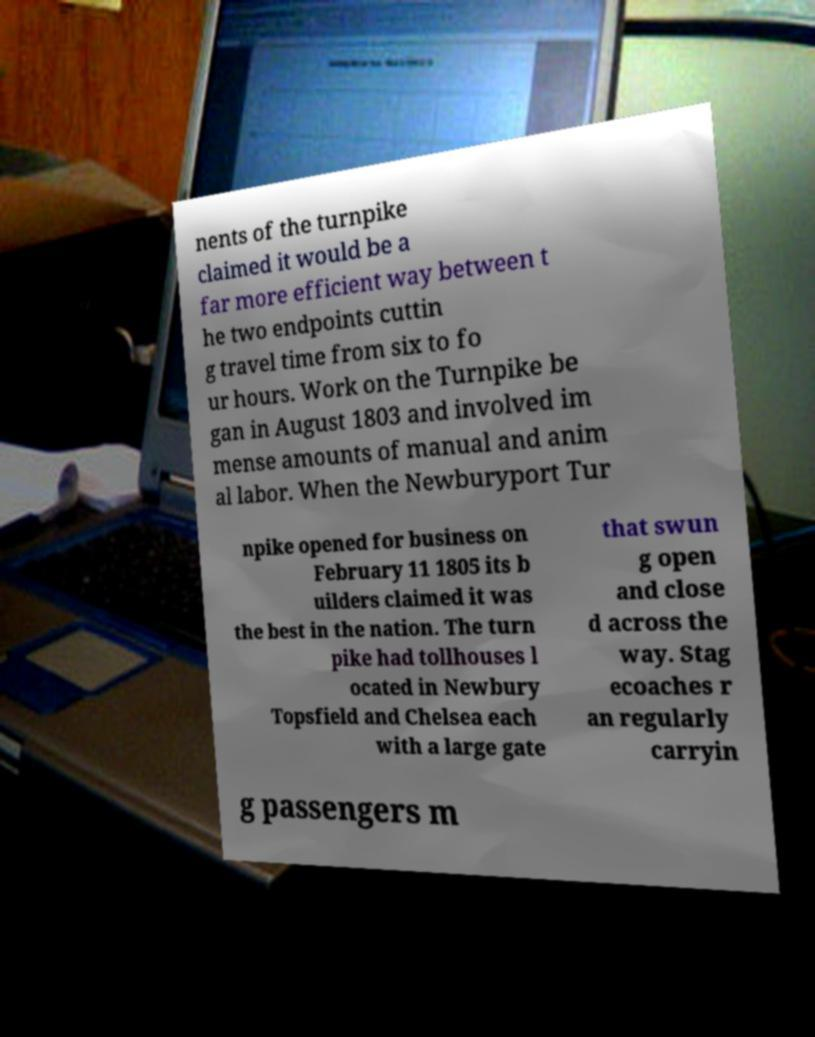What messages or text are displayed in this image? I need them in a readable, typed format. nents of the turnpike claimed it would be a far more efficient way between t he two endpoints cuttin g travel time from six to fo ur hours. Work on the Turnpike be gan in August 1803 and involved im mense amounts of manual and anim al labor. When the Newburyport Tur npike opened for business on February 11 1805 its b uilders claimed it was the best in the nation. The turn pike had tollhouses l ocated in Newbury Topsfield and Chelsea each with a large gate that swun g open and close d across the way. Stag ecoaches r an regularly carryin g passengers m 